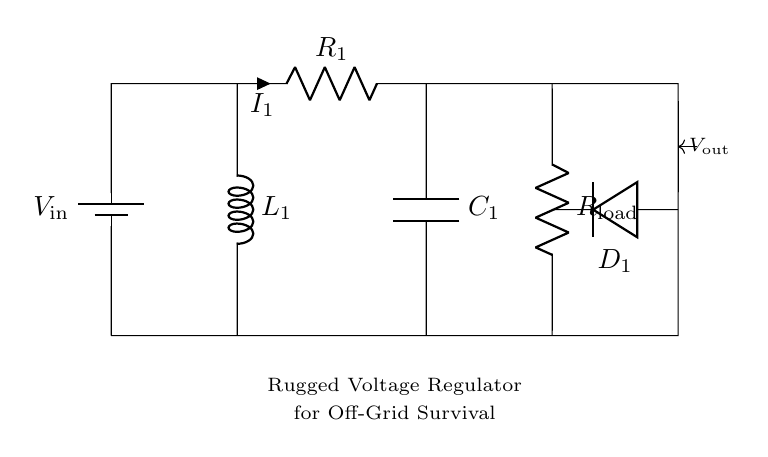What is the type of energy source used in this circuit? The circuit diagram shows a battery symbol, which indicates that a battery is the energy source providing direct current to the circuit.
Answer: battery What are the main components in this voltage regulation circuit? The main components depicted in the circuit include a battery, a resistor, an inductor, a capacitor, a diode, and a load resistor.
Answer: battery, resistor, inductor, capacitor, diode, load resistor What is the function of the diode in this circuit? The diode allows current to flow in one direction only, providing protection to the other components by blocking any reverse voltage that may occur, ensuring proper voltage regulation to the load.
Answer: current rectification What is the load connected to the circuit? The load is indicated by the symbol R_load, which represents a resistor connected in parallel with the output from the voltage regulation circuit.
Answer: resistor How do R, L, and C interact in this voltage regulation circuit? The resistor (R) dissipates energy as heat, the inductor (L) stores energy in a magnetic field when current flows through it, and the capacitor (C) stores and releases energy in the form of an electric field, helping to smooth voltage variations in this setup.
Answer: energy storage and smoothing What is the overall purpose of this circuit diagram? The overall purpose is to show a rugged voltage regulator designed specifically for off-grid survival systems, providing stable voltage output for various applications in survival shelters.
Answer: voltage regulation 